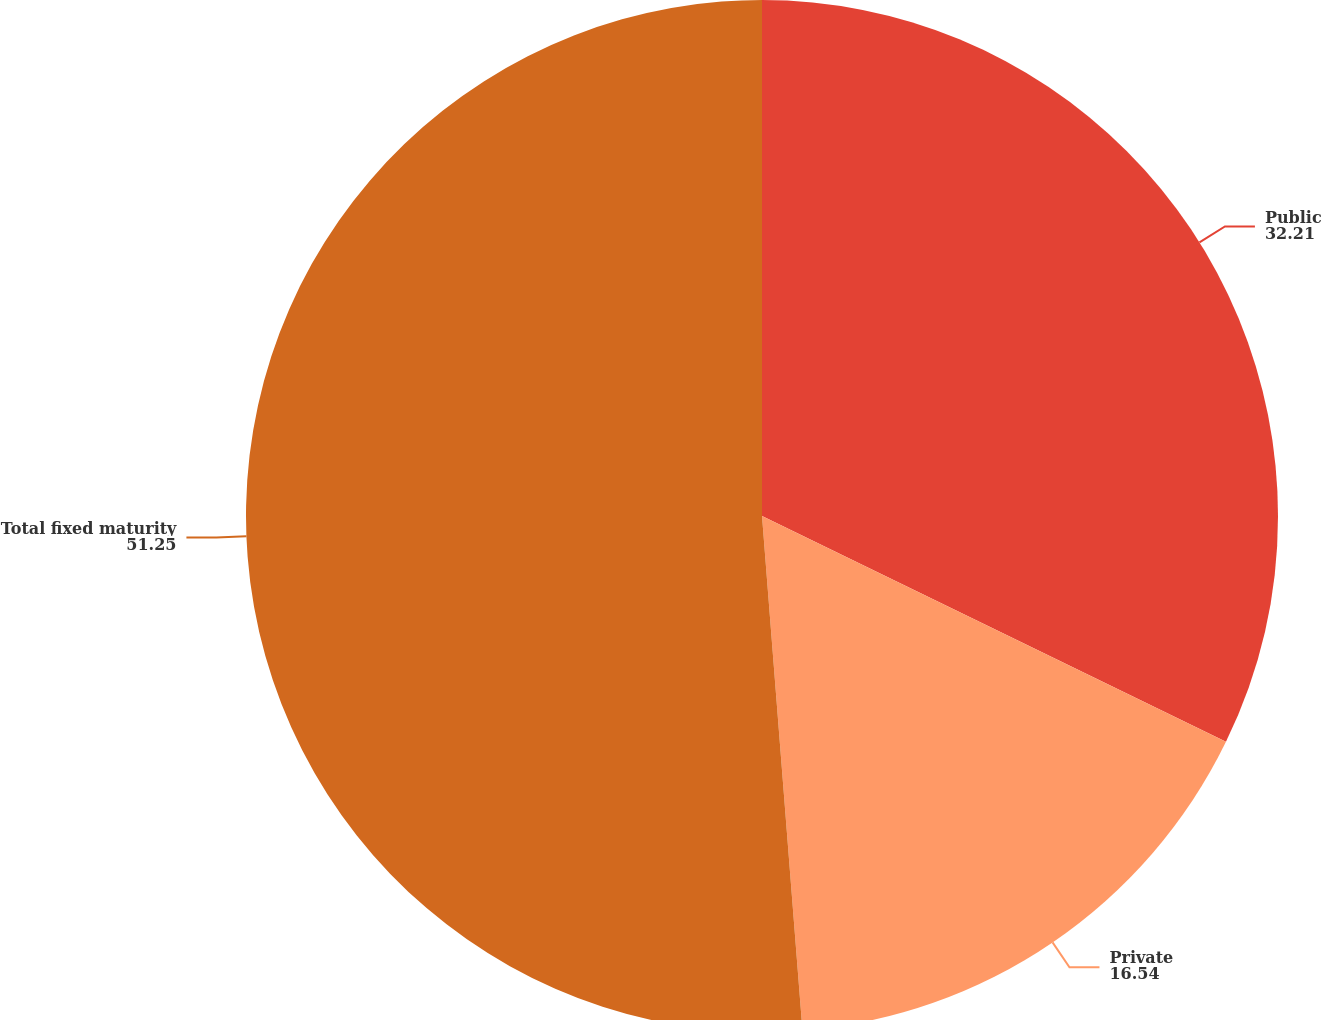Convert chart. <chart><loc_0><loc_0><loc_500><loc_500><pie_chart><fcel>Public<fcel>Private<fcel>Total fixed maturity<nl><fcel>32.21%<fcel>16.54%<fcel>51.25%<nl></chart> 